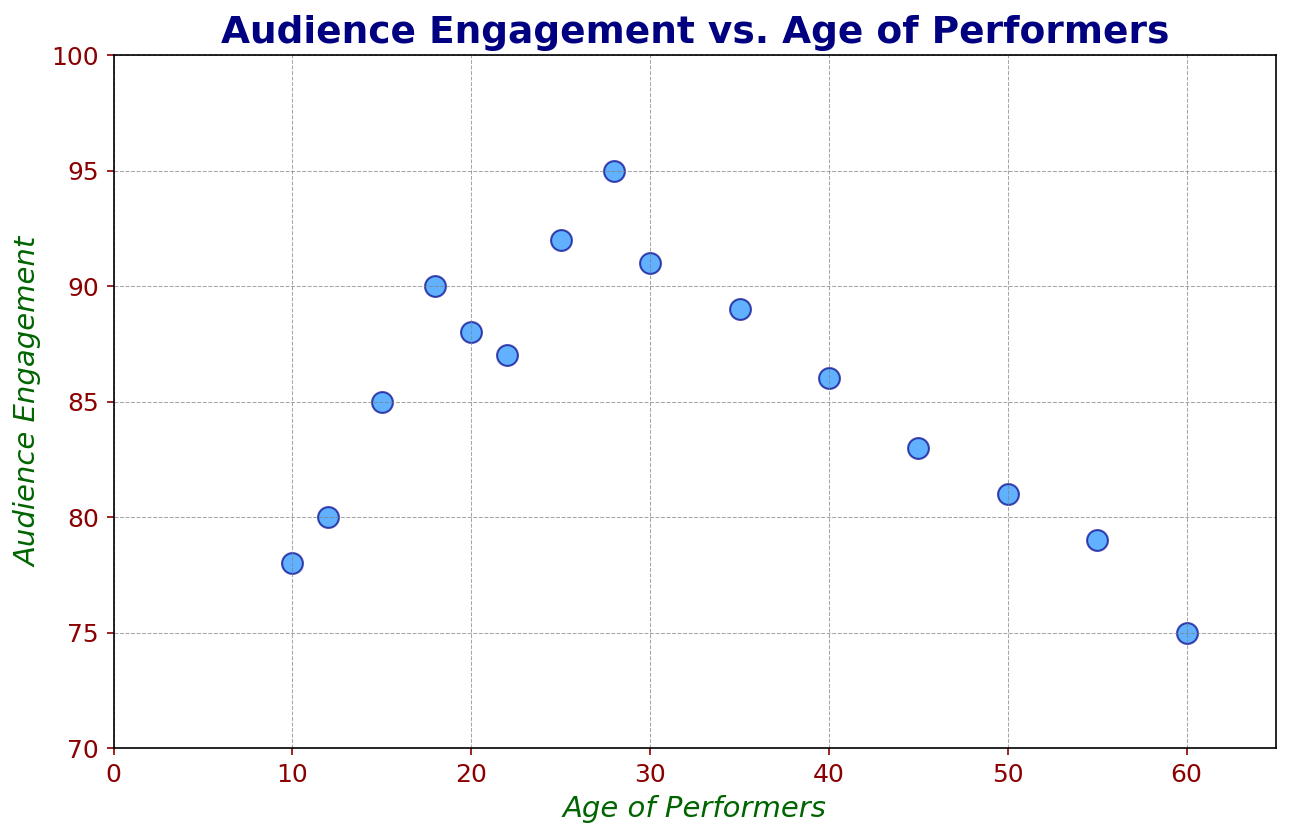what's the highest level of audience engagement and for which age group does it occur? The highest data point in the scatter plot is at age 28. The corresponding y-value, which indicates the audience engagement, is 95.
Answer: 95 at age 28 How does the audience engagement of 25-year-old performers compare to that of 30-year-old performers? Locate the points for ages 25 and 30 on the scatter plot. The engagement for age 25 is at 92, and for age 30, it is at 91. Comparing these two numbers shows that 25-year-olds have slightly higher engagement.
Answer: 25-year-olds have higher engagement than 30-year-olds Is the average audience engagement for performers aged 20 and above below or above 90? Calculate the average engagement of performers aged 20 and above (20, 22, 25, 28, 30, 35, 40, 45, 50, 55, 60). The sum is 88 + 87 + 92 + 95 + 91 + 89 + 86 + 83 + 81 + 79 + 75 = 956. There are 11 values, so the average is 956/11 ≈ 86.91. This is below 90.
Answer: Below 90 What is the difference in audience engagement between the youngest and the oldest performers in the dataset? The youngest performer is 10 years old with engagement at 78, and the oldest is 60 years old with engagement at 75. The difference is 78 - 75 = 3.
Answer: 3 Between which ages does audience engagement peak and then start to decline? Audience engagement increases from age 10 to 28, peaking at 95. After this point, it begins to decline.
Answer: Peaks at age 28, then declines What is the audience engagement trend from age 10 to age 20? Plot the points for ages 10, 12, 15, 18, and 20 to observe the trend. Engagement increases consistently from 78 to 90, then slightly drops to 88 at age 20.
Answer: Increases then slightly drops How much higher is the audience engagement for a 28-year-old performer compared to a 50-year-old performer? Engagement for age 28 is 95 and for age 50 is 81. Subtracting these values, 95 - 81, gives 14.
Answer: 14 Is there any performer age where the audience engagement exactly matches 85? Check the y-values on the scatter plot. At age 15, the audience engagement is exactly 85.
Answer: Yes, age 15 